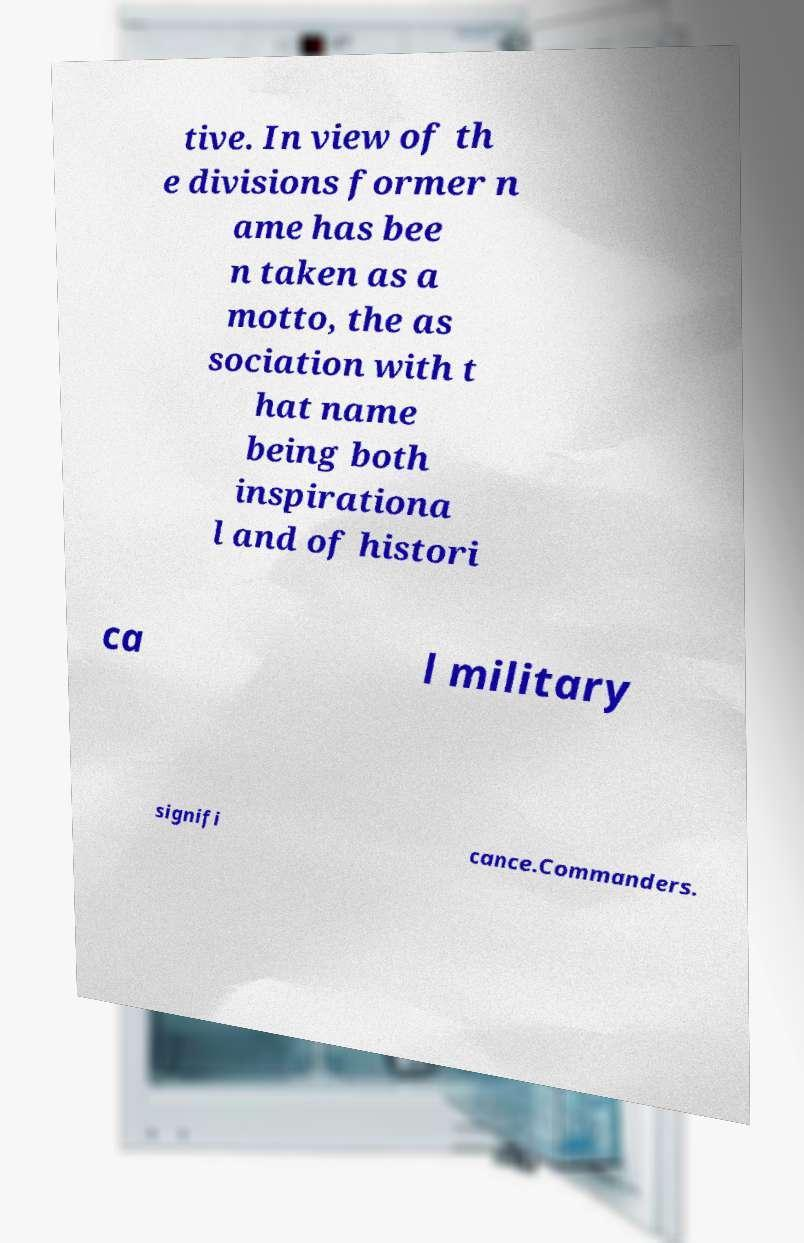There's text embedded in this image that I need extracted. Can you transcribe it verbatim? tive. In view of th e divisions former n ame has bee n taken as a motto, the as sociation with t hat name being both inspirationa l and of histori ca l military signifi cance.Commanders. 